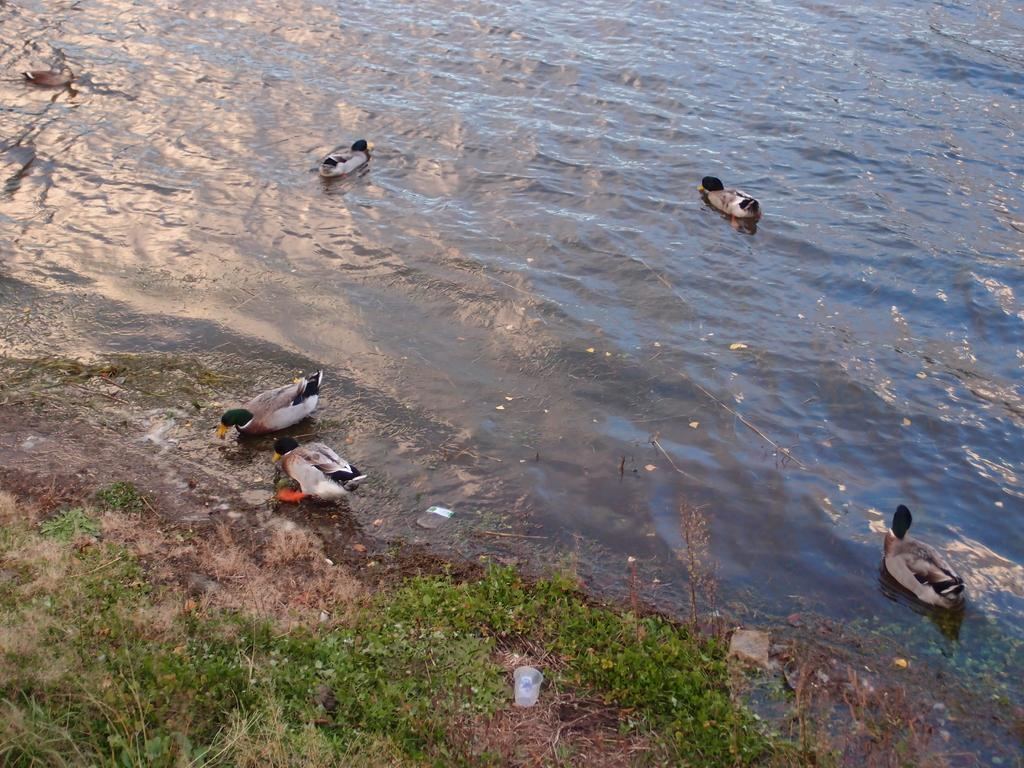What is happening in the water in the image? There are many birds in the water. What object can be seen near the grass? There is a plastic glass near the grass. Can you describe the bird in the image? A bird is visible in the image, and it is drinking. Where is the father in the image? There is no father present in the image. What type of bear can be seen interacting with the birds in the water? There are no bears present in the image; it features birds in the water and a bird drinking from a plastic glass. 